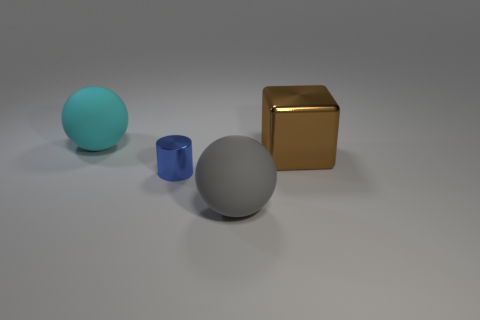Are there the same number of brown objects behind the large cyan sphere and big objects? After examining the image, the answer is no. There is one large brown cube behind the large cyan sphere, but if we consider all 'big' objects, there are several, including the cyan sphere itself, a large grey sphere, and the brown cube. The terms 'large' and 'big' may refer to different size categories, but taking the most inclusive interpretation, their numbers differ. 